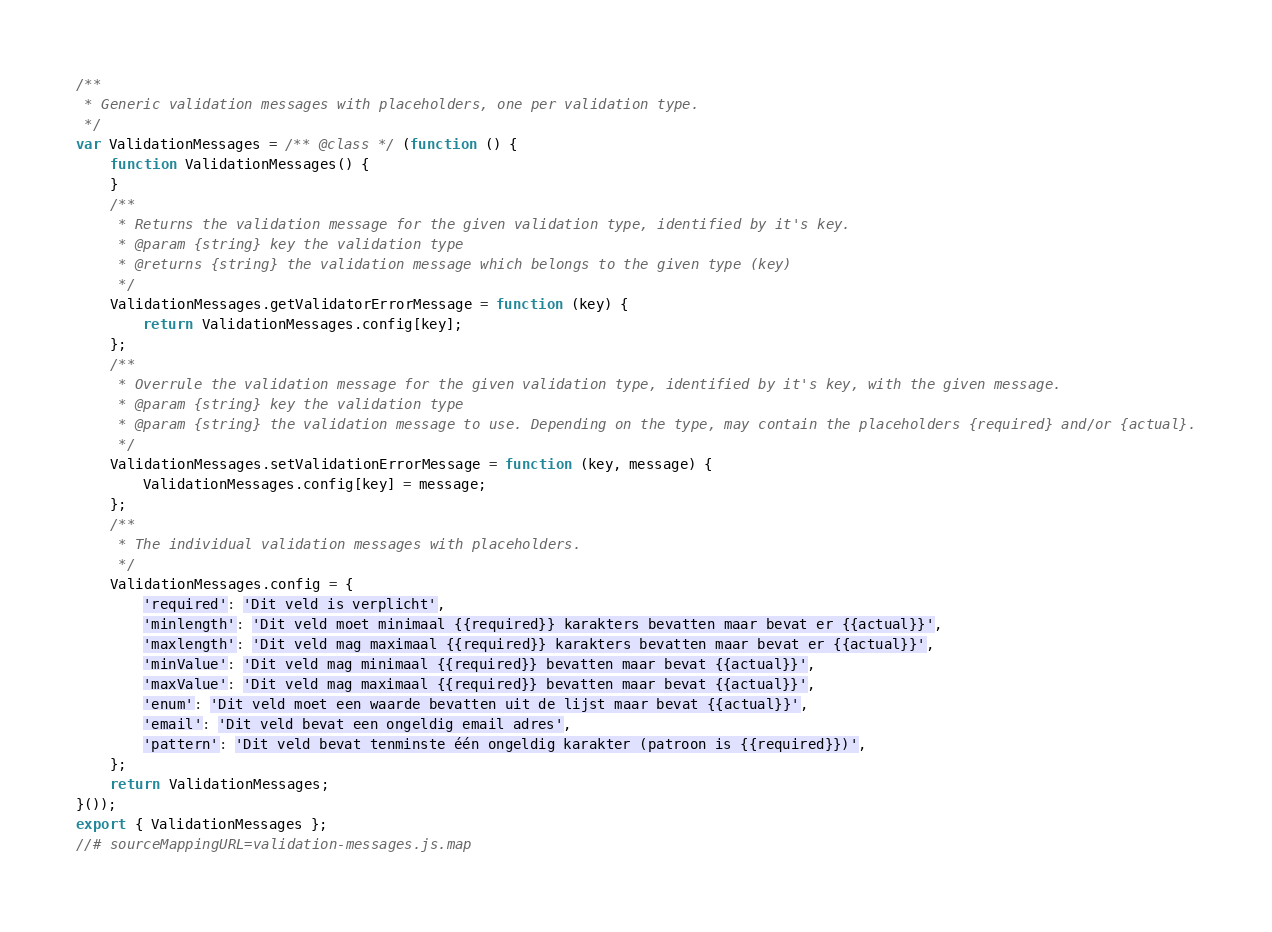<code> <loc_0><loc_0><loc_500><loc_500><_JavaScript_>/**
 * Generic validation messages with placeholders, one per validation type.
 */
var ValidationMessages = /** @class */ (function () {
    function ValidationMessages() {
    }
    /**
     * Returns the validation message for the given validation type, identified by it's key.
     * @param {string} key the validation type
     * @returns {string} the validation message which belongs to the given type (key)
     */
    ValidationMessages.getValidatorErrorMessage = function (key) {
        return ValidationMessages.config[key];
    };
    /**
     * Overrule the validation message for the given validation type, identified by it's key, with the given message.
     * @param {string} key the validation type
     * @param {string} the validation message to use. Depending on the type, may contain the placeholders {required} and/or {actual}.
     */
    ValidationMessages.setValidationErrorMessage = function (key, message) {
        ValidationMessages.config[key] = message;
    };
    /**
     * The individual validation messages with placeholders.
     */
    ValidationMessages.config = {
        'required': 'Dit veld is verplicht',
        'minlength': 'Dit veld moet minimaal {{required}} karakters bevatten maar bevat er {{actual}}',
        'maxlength': 'Dit veld mag maximaal {{required}} karakters bevatten maar bevat er {{actual}}',
        'minValue': 'Dit veld mag minimaal {{required}} bevatten maar bevat {{actual}}',
        'maxValue': 'Dit veld mag maximaal {{required}} bevatten maar bevat {{actual}}',
        'enum': 'Dit veld moet een waarde bevatten uit de lijst maar bevat {{actual}}',
        'email': 'Dit veld bevat een ongeldig email adres',
        'pattern': 'Dit veld bevat tenminste één ongeldig karakter (patroon is {{required}})',
    };
    return ValidationMessages;
}());
export { ValidationMessages };
//# sourceMappingURL=validation-messages.js.map</code> 